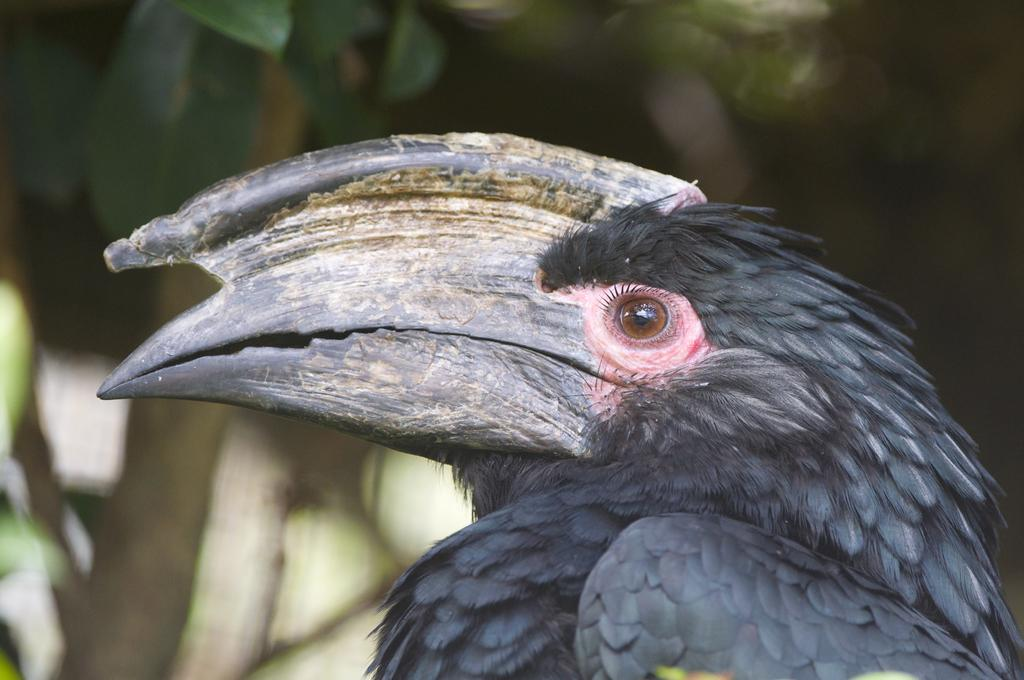What type of bird is in the image? There is a bird named Hornbill in the image. What color is the Hornbill in the image? The bird is black in color. Can you describe the background of the image? The background of the image appears blurry. What type of spy equipment can be seen in the image? There is no spy equipment visible in the image; it features a black Hornbill bird with a blurry background. 